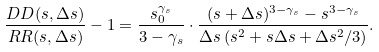<formula> <loc_0><loc_0><loc_500><loc_500>\frac { D D ( s , \Delta s ) } { R R ( s , \Delta s ) } - 1 = \frac { s _ { 0 } ^ { \gamma _ { s } } } { 3 - \gamma _ { s } } \cdot \frac { ( s + \Delta s ) ^ { 3 - \gamma _ { s } } - s ^ { 3 - \gamma _ { s } } } { \Delta s \, ( s ^ { 2 } + s \Delta s + \Delta s ^ { 2 } / 3 ) } .</formula> 